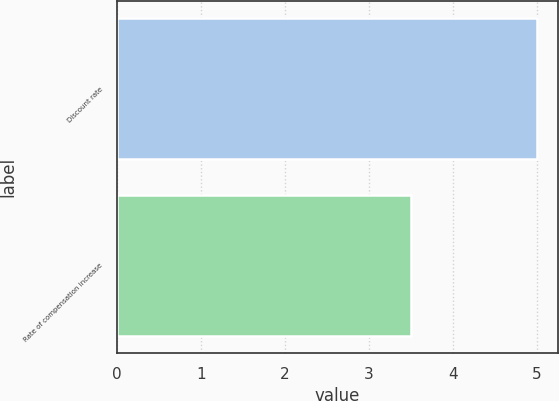<chart> <loc_0><loc_0><loc_500><loc_500><bar_chart><fcel>Discount rate<fcel>Rate of compensation increase<nl><fcel>5<fcel>3.5<nl></chart> 